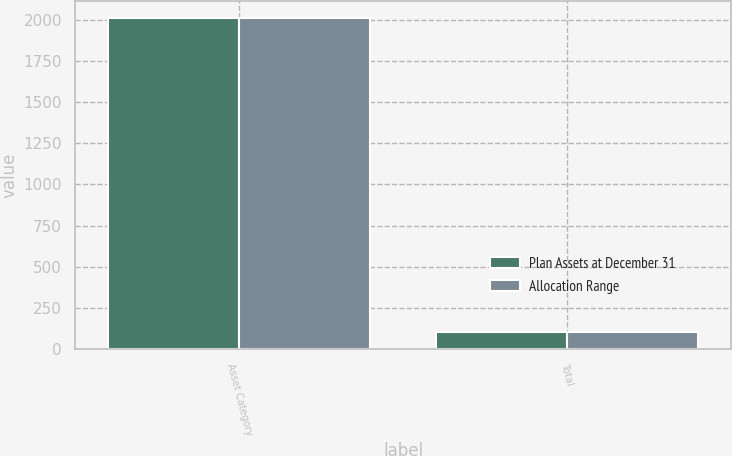<chart> <loc_0><loc_0><loc_500><loc_500><stacked_bar_chart><ecel><fcel>Asset Category<fcel>Total<nl><fcel>Plan Assets at December 31<fcel>2015<fcel>100<nl><fcel>Allocation Range<fcel>2014<fcel>100<nl></chart> 